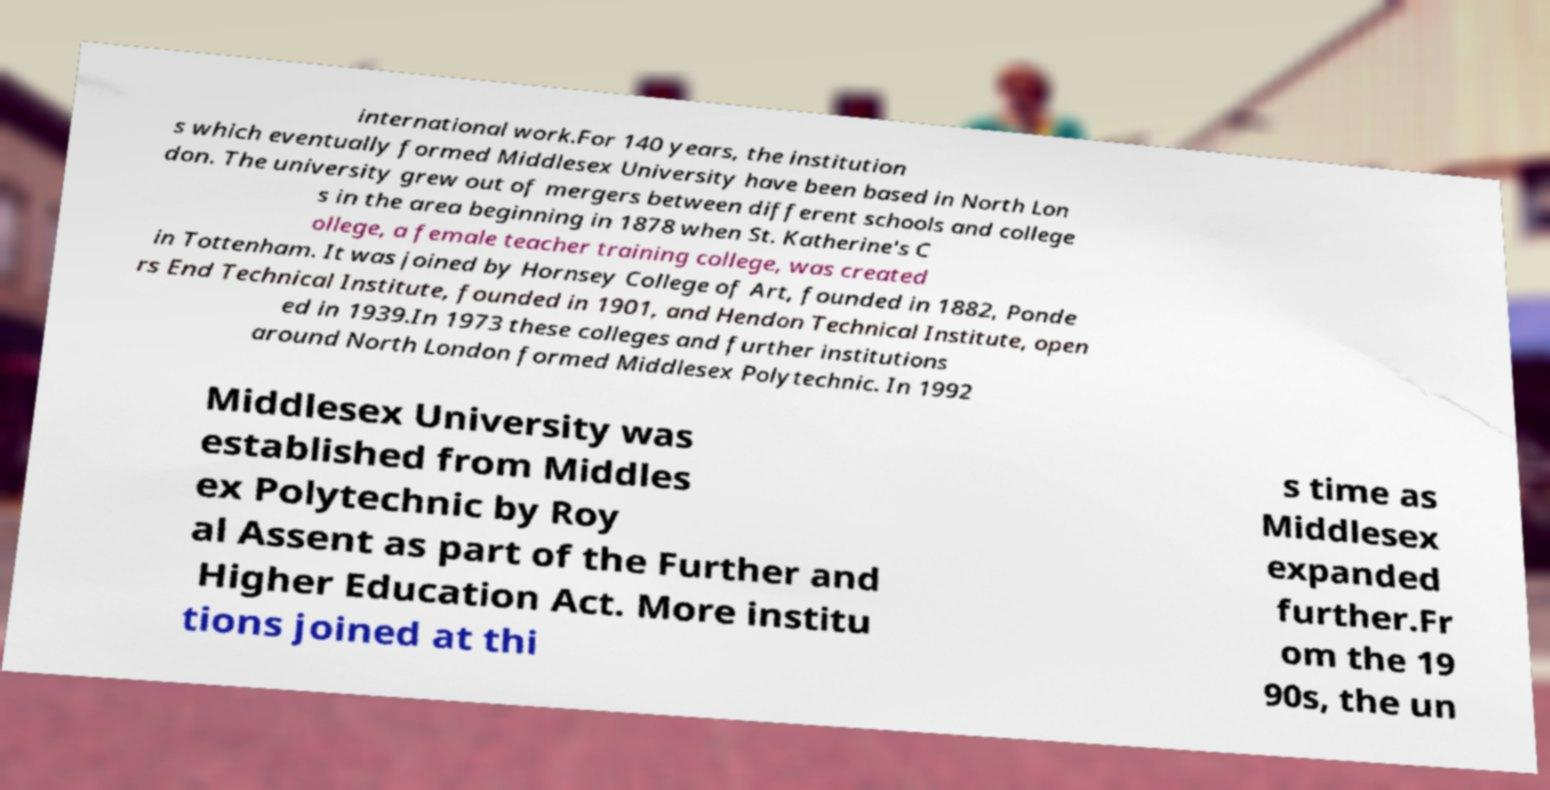For documentation purposes, I need the text within this image transcribed. Could you provide that? international work.For 140 years, the institution s which eventually formed Middlesex University have been based in North Lon don. The university grew out of mergers between different schools and college s in the area beginning in 1878 when St. Katherine's C ollege, a female teacher training college, was created in Tottenham. It was joined by Hornsey College of Art, founded in 1882, Ponde rs End Technical Institute, founded in 1901, and Hendon Technical Institute, open ed in 1939.In 1973 these colleges and further institutions around North London formed Middlesex Polytechnic. In 1992 Middlesex University was established from Middles ex Polytechnic by Roy al Assent as part of the Further and Higher Education Act. More institu tions joined at thi s time as Middlesex expanded further.Fr om the 19 90s, the un 